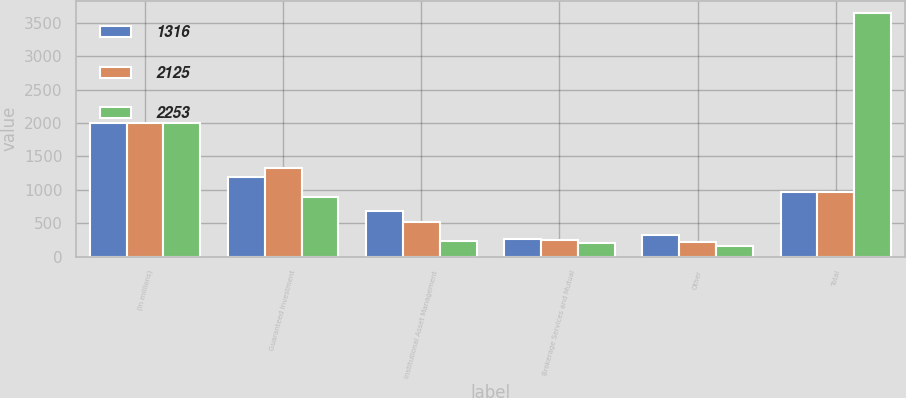<chart> <loc_0><loc_0><loc_500><loc_500><stacked_bar_chart><ecel><fcel>(in millions)<fcel>Guaranteed Investment<fcel>Institutional Asset Management<fcel>Brokerage Services and Mutual<fcel>Other<fcel>Total<nl><fcel>1316<fcel>2005<fcel>1185<fcel>686<fcel>257<fcel>326<fcel>967<nl><fcel>2125<fcel>2004<fcel>1328<fcel>515<fcel>249<fcel>224<fcel>967<nl><fcel>2253<fcel>2003<fcel>885<fcel>227<fcel>206<fcel>155<fcel>3651<nl></chart> 